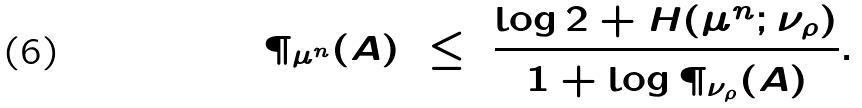Convert formula to latex. <formula><loc_0><loc_0><loc_500><loc_500>\P _ { \mu ^ { n } } ( A ) \ \leq \ \frac { \log 2 + H ( \mu ^ { n } ; \nu _ { \rho } ) } { 1 + \log \P _ { \nu _ { \rho } } ( A ) } .</formula> 